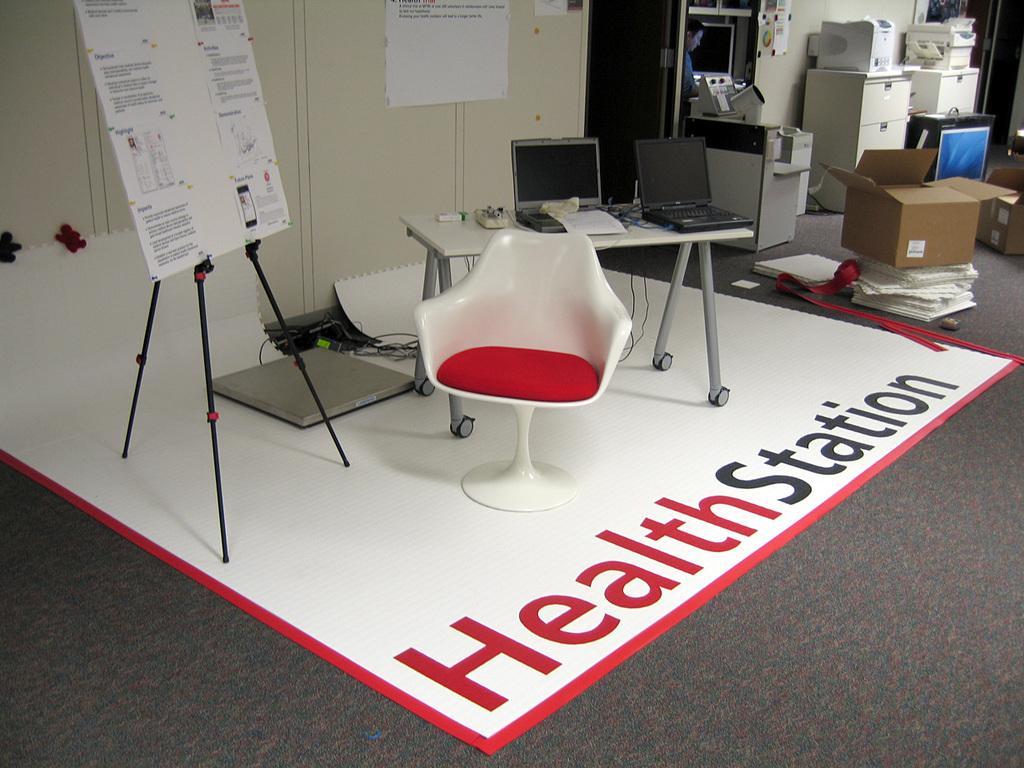Can you describe this image briefly? In this image, I can see a chair, white board with a stand, cardboard boxes, a table with laptops and few other things on it and machines. At the top of the image, I can see a paper and posters attached to the wall. There is a person standing. It looks like a banner on the floor. 